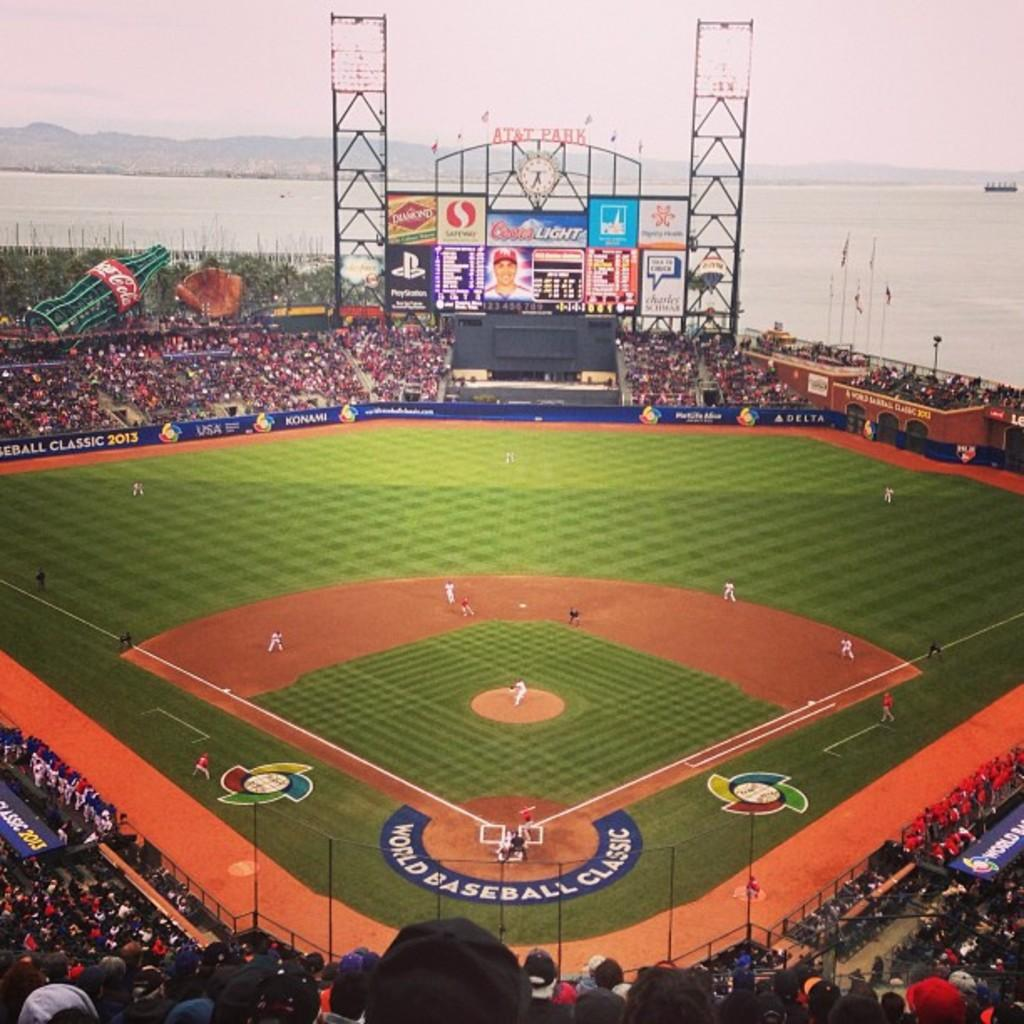Provide a one-sentence caption for the provided image. A packed baseball field with an ongoing World Baseball Classic game. 